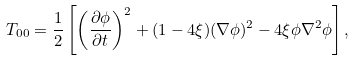Convert formula to latex. <formula><loc_0><loc_0><loc_500><loc_500>T _ { 0 0 } = \frac { 1 } { 2 } \left [ \left ( \frac { \partial \phi } { \partial t } \right ) ^ { 2 } + ( 1 - 4 \xi ) ( \nabla \phi ) ^ { 2 } - 4 \xi \phi \nabla ^ { 2 } \phi \right ] ,</formula> 